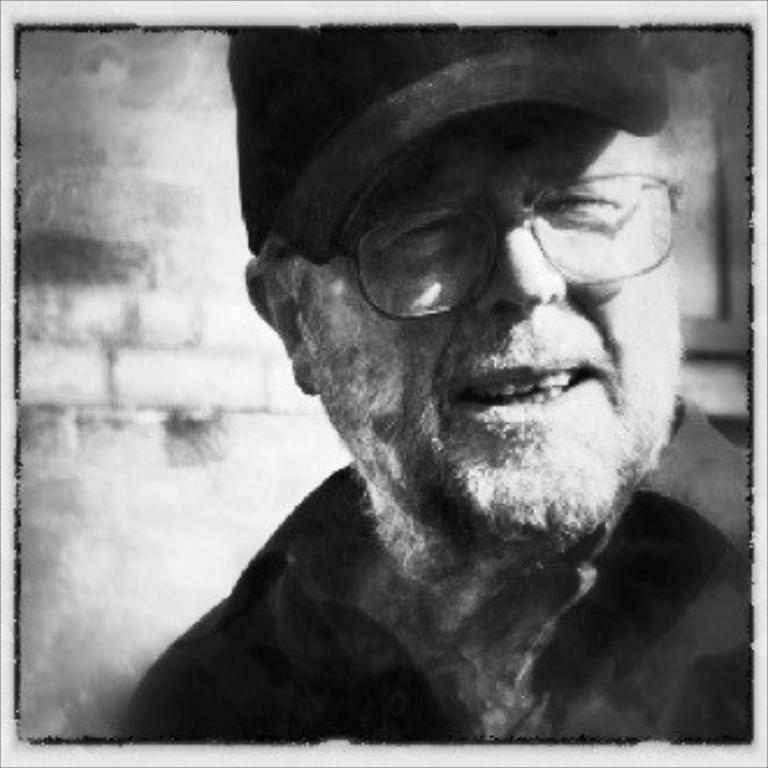What is the main subject of the image? The main subject of the image is a man. What can be observed about the man's appearance? The man is wearing spectacles and a cap. What is the man's facial expression? The man is smiling. What is visible in the background of the image? There is a wall in the background of the image. What type of teeth does the man have in the image? There is no information about the man's teeth in the image, so we cannot determine their type. Can you tell me what the man's desire is in the image? There is no information about the man's desires in the image, so we cannot determine what they might be. 